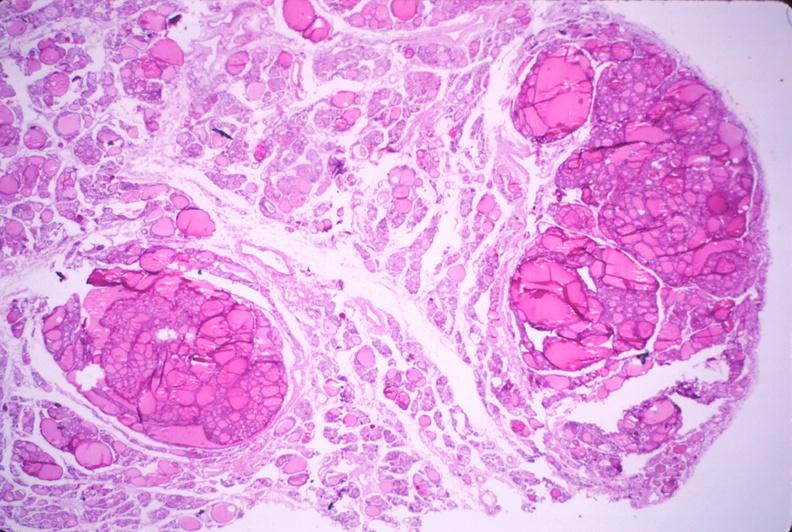s endocrine present?
Answer the question using a single word or phrase. Yes 